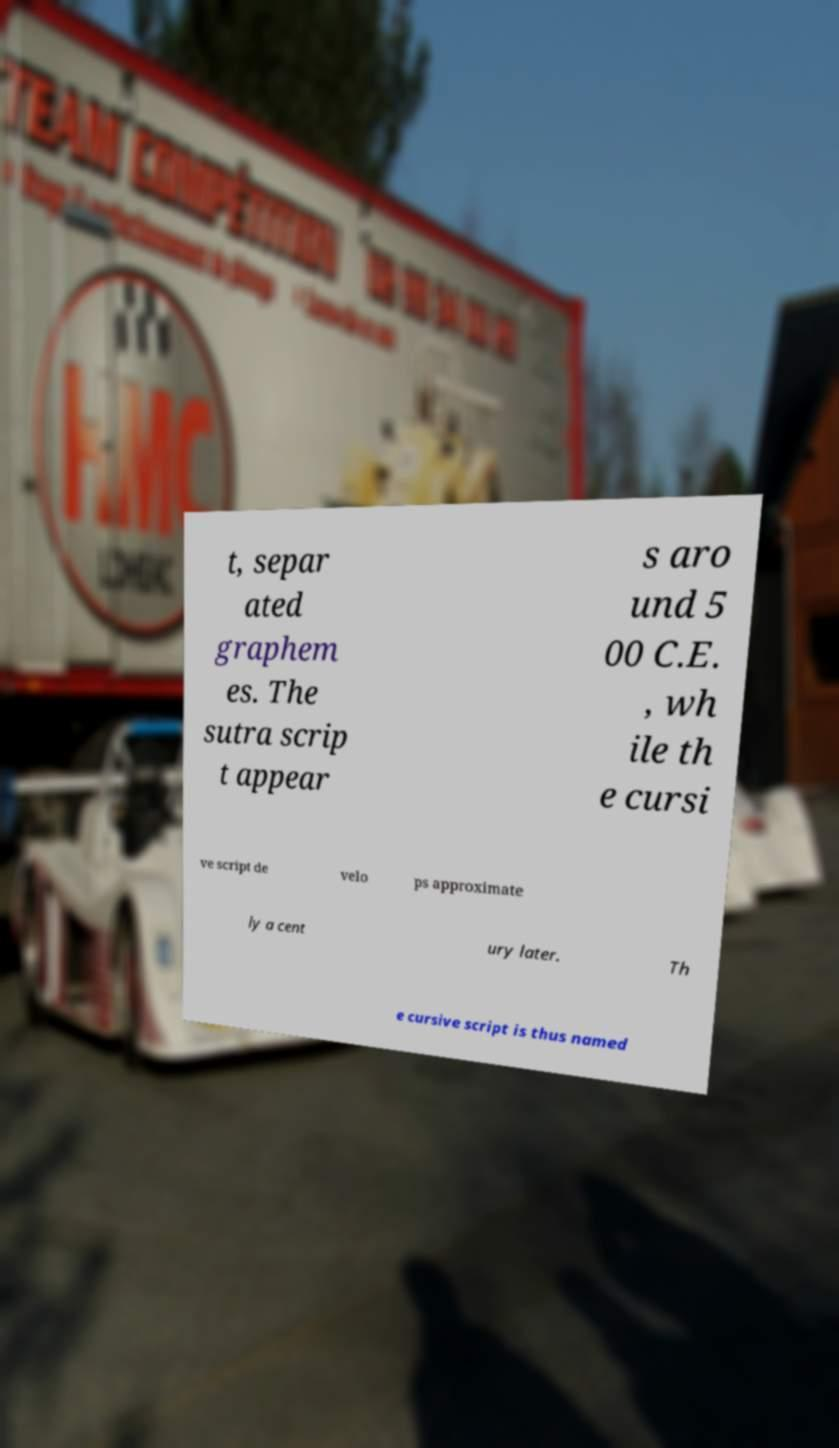Could you extract and type out the text from this image? t, separ ated graphem es. The sutra scrip t appear s aro und 5 00 C.E. , wh ile th e cursi ve script de velo ps approximate ly a cent ury later. Th e cursive script is thus named 